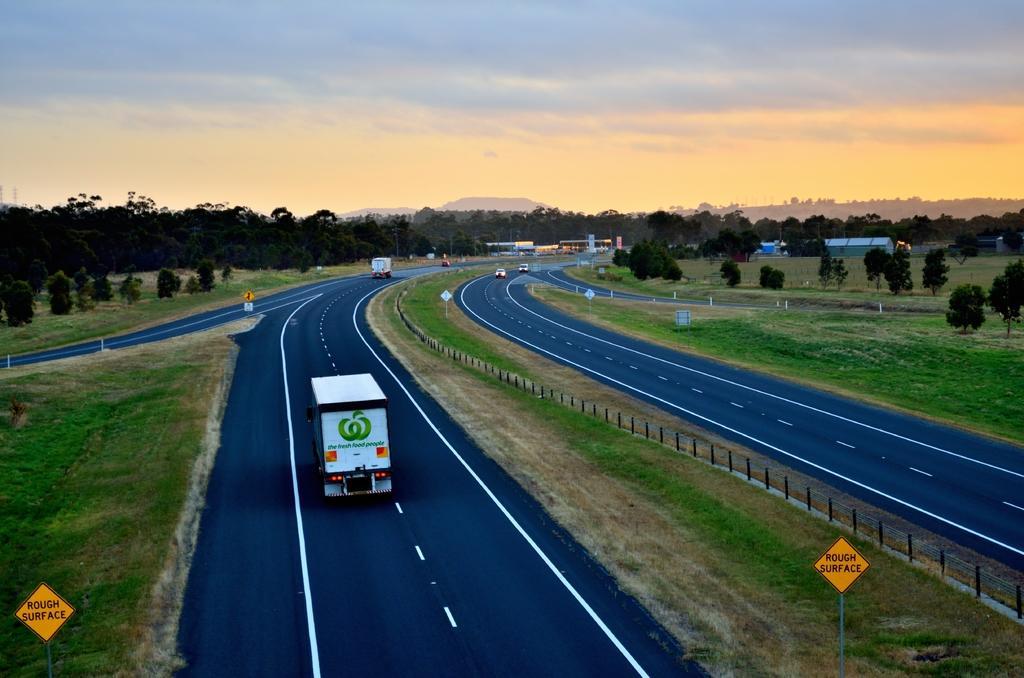Please provide a concise description of this image. This picture is clicked outside the city. In this picture, we see vehicles moving on the road. On either side of the picture, we see yellow color boards with some text written on it. There are trees and buildings in the background. We even see the hills. At the top of the picture, we see the sky. 